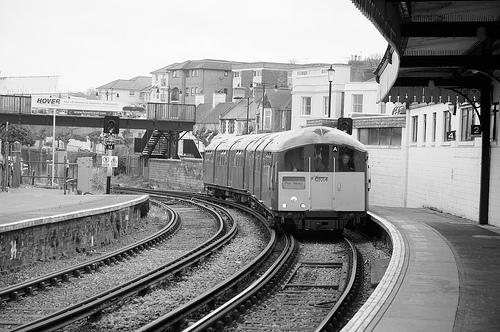Question: where was this picture taken?
Choices:
A. At a bus stop.
B. At an airport.
C. In a parking lot.
D. It was taken at a train station.
Answer with the letter. Answer: D Question: who is in the picture?
Choices:
A. A child.
B. Nobody is in the picture.
C. A woman.
D. A man.
Answer with the letter. Answer: B 